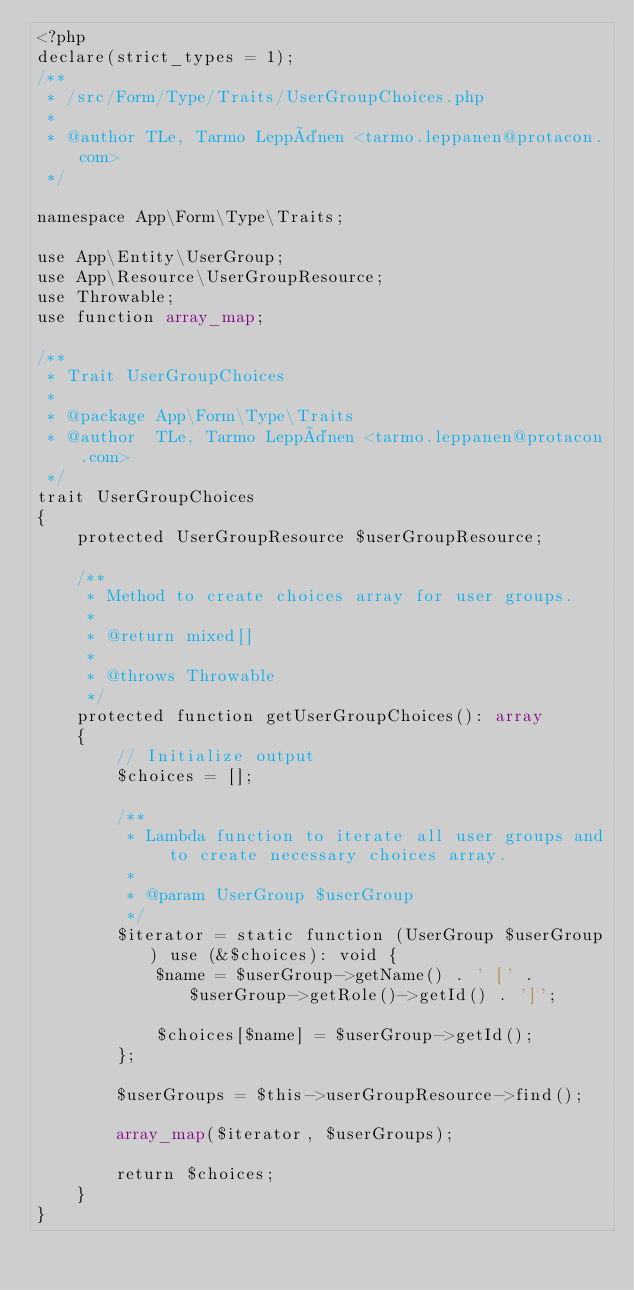Convert code to text. <code><loc_0><loc_0><loc_500><loc_500><_PHP_><?php
declare(strict_types = 1);
/**
 * /src/Form/Type/Traits/UserGroupChoices.php
 *
 * @author TLe, Tarmo Leppänen <tarmo.leppanen@protacon.com>
 */

namespace App\Form\Type\Traits;

use App\Entity\UserGroup;
use App\Resource\UserGroupResource;
use Throwable;
use function array_map;

/**
 * Trait UserGroupChoices
 *
 * @package App\Form\Type\Traits
 * @author  TLe, Tarmo Leppänen <tarmo.leppanen@protacon.com>
 */
trait UserGroupChoices
{
    protected UserGroupResource $userGroupResource;

    /**
     * Method to create choices array for user groups.
     *
     * @return mixed[]
     *
     * @throws Throwable
     */
    protected function getUserGroupChoices(): array
    {
        // Initialize output
        $choices = [];

        /**
         * Lambda function to iterate all user groups and to create necessary choices array.
         *
         * @param UserGroup $userGroup
         */
        $iterator = static function (UserGroup $userGroup) use (&$choices): void {
            $name = $userGroup->getName() . ' [' . $userGroup->getRole()->getId() . ']';

            $choices[$name] = $userGroup->getId();
        };

        $userGroups = $this->userGroupResource->find();

        array_map($iterator, $userGroups);

        return $choices;
    }
}
</code> 